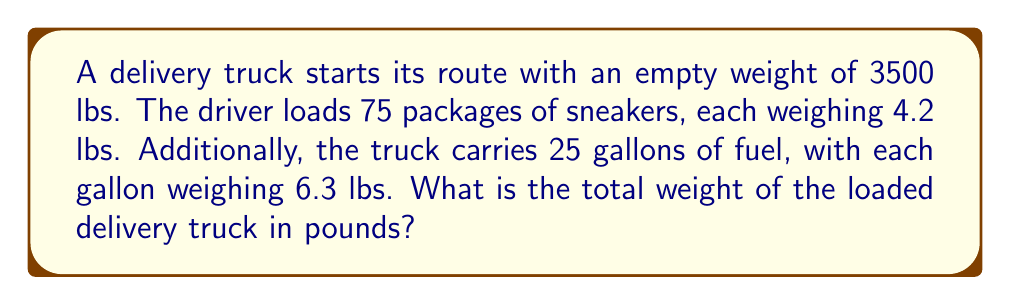Can you answer this question? Let's break this problem down step-by-step:

1. Calculate the weight of the sneaker packages:
   Number of packages = 75
   Weight per package = 4.2 lbs
   Total weight of packages = $75 \times 4.2 = 315$ lbs

2. Calculate the weight of the fuel:
   Number of gallons = 25
   Weight per gallon = 6.3 lbs
   Total weight of fuel = $25 \times 6.3 = 157.5$ lbs

3. Sum up all the weights:
   Empty truck weight = 3500 lbs
   Sneaker packages weight = 315 lbs
   Fuel weight = 157.5 lbs

   Total weight = $3500 + 315 + 157.5 = 3972.5$ lbs

Therefore, the total weight of the loaded delivery truck is 3972.5 lbs.
Answer: 3972.5 lbs 